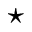<formula> <loc_0><loc_0><loc_500><loc_500>^ { * }</formula> 